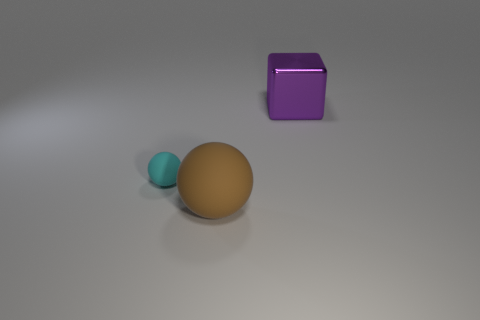Add 3 big objects. How many objects exist? 6 Subtract all balls. How many objects are left? 1 Subtract 1 spheres. How many spheres are left? 1 Subtract all green cylinders. How many red cubes are left? 0 Subtract all blue spheres. Subtract all purple cubes. How many spheres are left? 2 Subtract all small blue rubber cylinders. Subtract all cyan rubber things. How many objects are left? 2 Add 1 purple metal blocks. How many purple metal blocks are left? 2 Add 2 cyan metal cylinders. How many cyan metal cylinders exist? 2 Subtract 0 blue blocks. How many objects are left? 3 